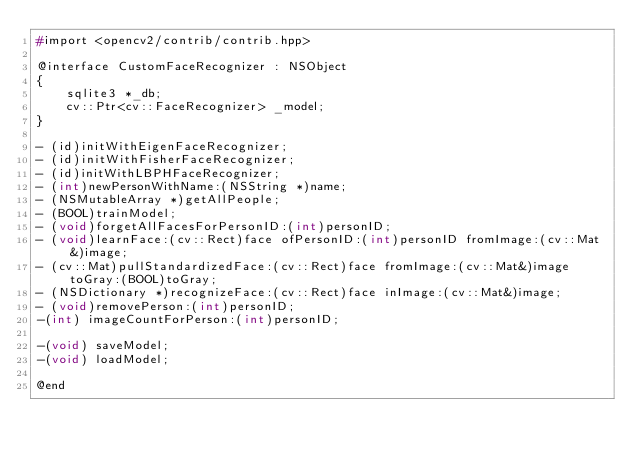<code> <loc_0><loc_0><loc_500><loc_500><_C_>#import <opencv2/contrib/contrib.hpp>

@interface CustomFaceRecognizer : NSObject
{
    sqlite3 *_db;
    cv::Ptr<cv::FaceRecognizer> _model;
}

- (id)initWithEigenFaceRecognizer;
- (id)initWithFisherFaceRecognizer;
- (id)initWithLBPHFaceRecognizer;
- (int)newPersonWithName:(NSString *)name;
- (NSMutableArray *)getAllPeople;
- (BOOL)trainModel;
- (void)forgetAllFacesForPersonID:(int)personID;
- (void)learnFace:(cv::Rect)face ofPersonID:(int)personID fromImage:(cv::Mat&)image;
- (cv::Mat)pullStandardizedFace:(cv::Rect)face fromImage:(cv::Mat&)image toGray:(BOOL)toGray;
- (NSDictionary *)recognizeFace:(cv::Rect)face inImage:(cv::Mat&)image;
- (void)removePerson:(int)personID;
-(int) imageCountForPerson:(int)personID;

-(void) saveModel;
-(void) loadModel;

@end
</code> 